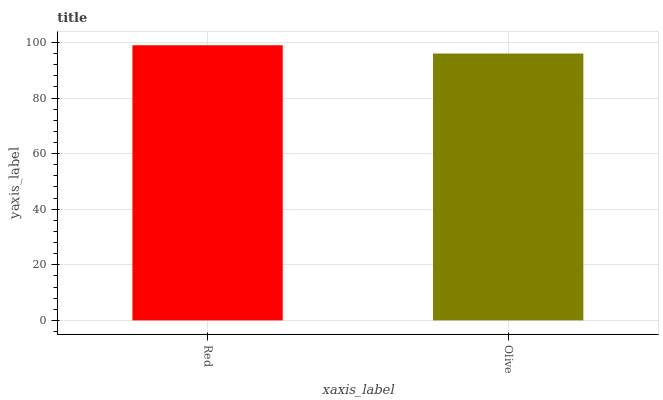Is Olive the minimum?
Answer yes or no. Yes. Is Red the maximum?
Answer yes or no. Yes. Is Olive the maximum?
Answer yes or no. No. Is Red greater than Olive?
Answer yes or no. Yes. Is Olive less than Red?
Answer yes or no. Yes. Is Olive greater than Red?
Answer yes or no. No. Is Red less than Olive?
Answer yes or no. No. Is Red the high median?
Answer yes or no. Yes. Is Olive the low median?
Answer yes or no. Yes. Is Olive the high median?
Answer yes or no. No. Is Red the low median?
Answer yes or no. No. 